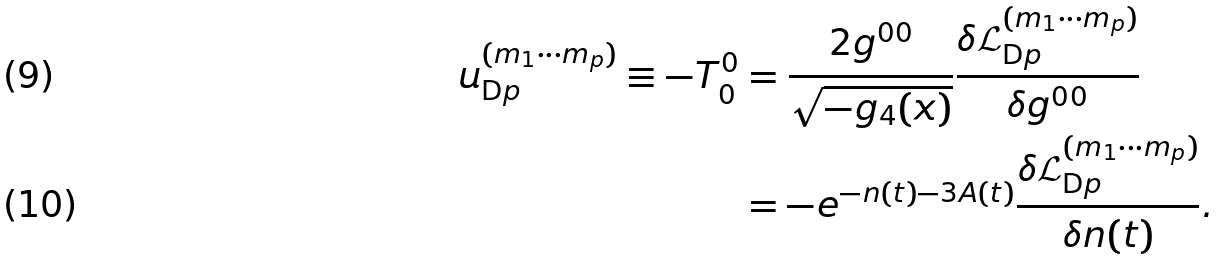<formula> <loc_0><loc_0><loc_500><loc_500>u _ { \text {D} p } ^ { ( m _ { 1 } \cdots m _ { p } ) } \equiv - T ^ { 0 } _ { 0 } & = \frac { 2 g ^ { 0 0 } } { \sqrt { - g _ { 4 } ( x ) } } \frac { \delta \mathcal { L } _ { \text {D} p } ^ { ( m _ { 1 } \cdots m _ { p } ) } } { \delta g ^ { 0 0 } } \\ & = - e ^ { - n ( t ) - 3 A ( t ) } \frac { \delta \mathcal { L } _ { \text {D} p } ^ { ( m _ { 1 } \cdots m _ { p } ) } } { \delta n ( t ) } .</formula> 